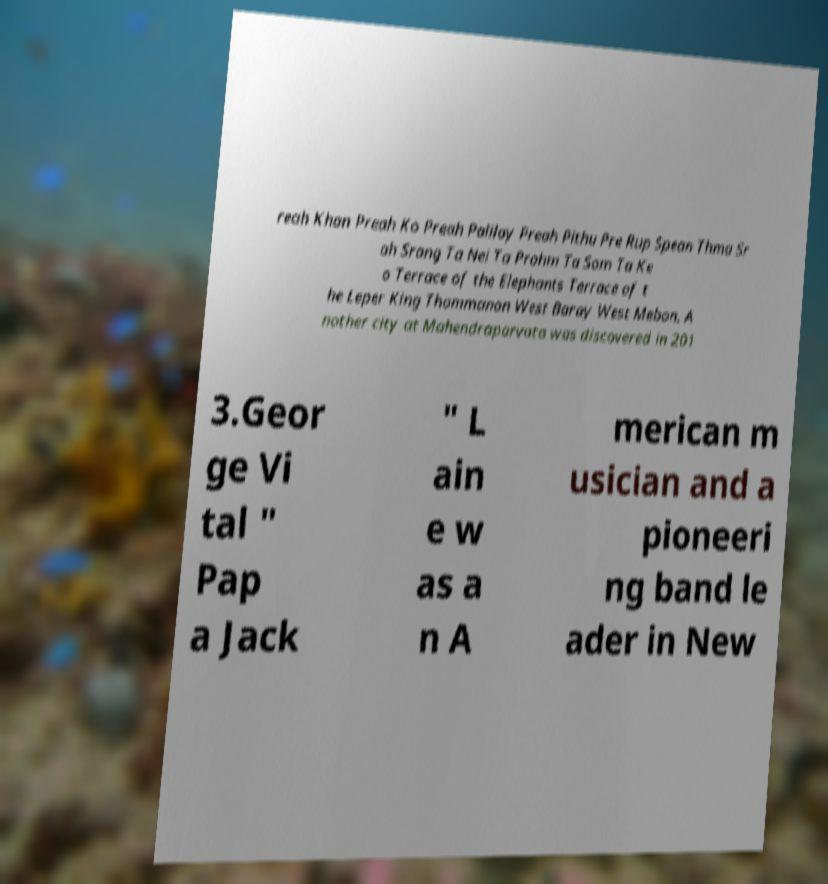There's text embedded in this image that I need extracted. Can you transcribe it verbatim? reah Khan Preah Ko Preah Palilay Preah Pithu Pre Rup Spean Thma Sr ah Srang Ta Nei Ta Prohm Ta Som Ta Ke o Terrace of the Elephants Terrace of t he Leper King Thommanon West Baray West Mebon. A nother city at Mahendraparvata was discovered in 201 3.Geor ge Vi tal " Pap a Jack " L ain e w as a n A merican m usician and a pioneeri ng band le ader in New 